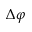<formula> <loc_0><loc_0><loc_500><loc_500>\Delta \varphi</formula> 